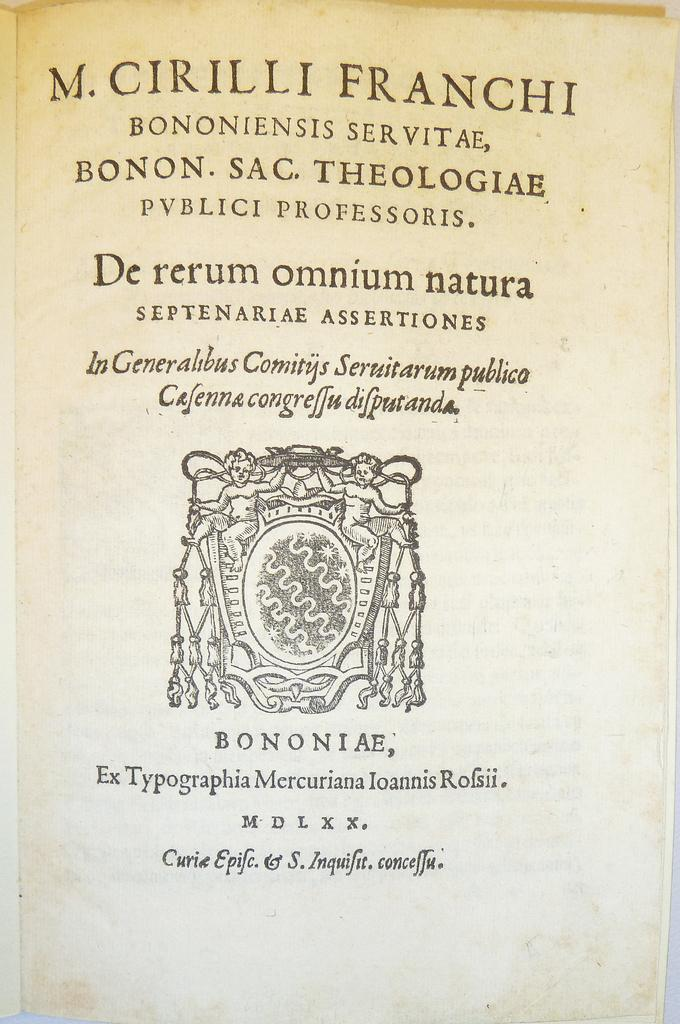<image>
Create a compact narrative representing the image presented. A very old book has a publication date of M D L X X on its title page. 